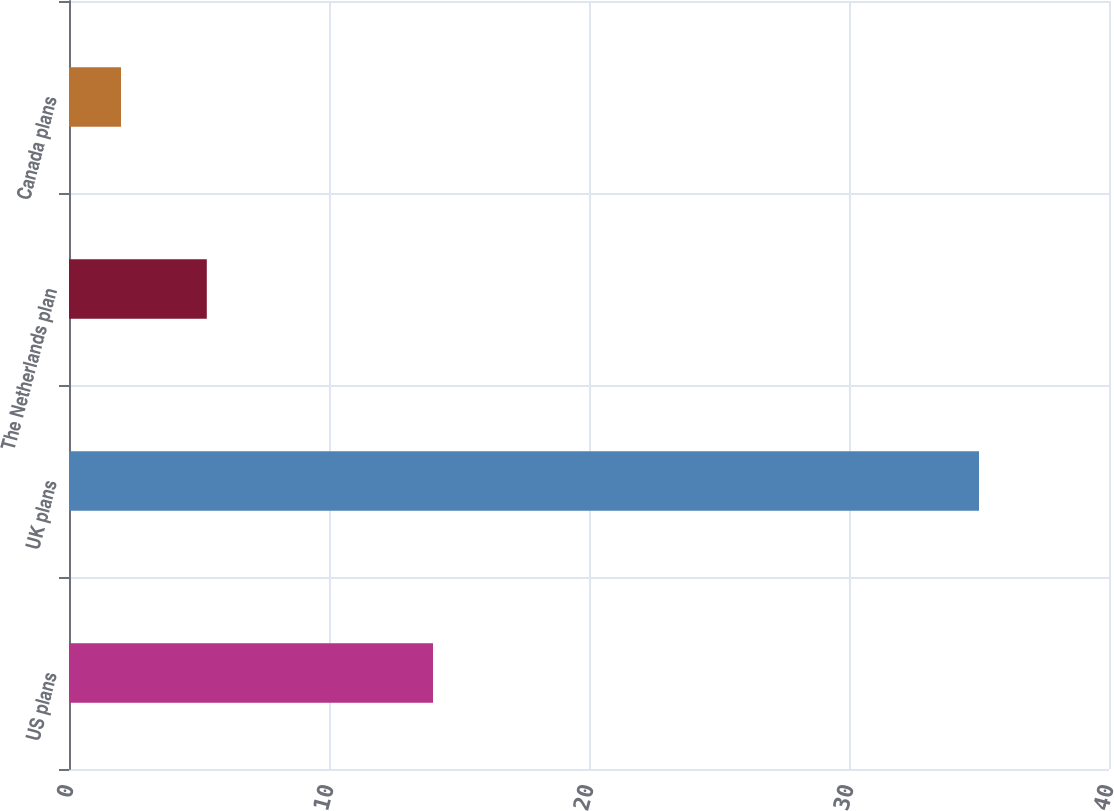<chart> <loc_0><loc_0><loc_500><loc_500><bar_chart><fcel>US plans<fcel>UK plans<fcel>The Netherlands plan<fcel>Canada plans<nl><fcel>14<fcel>35<fcel>5.3<fcel>2<nl></chart> 